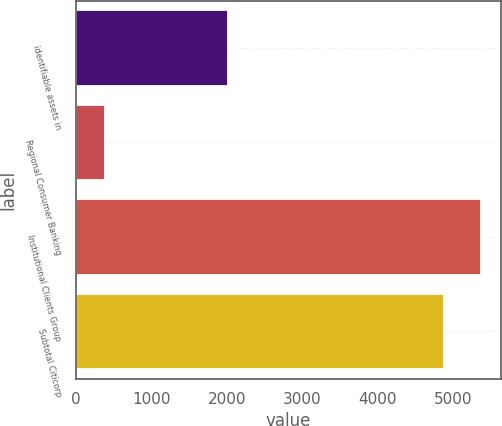Convert chart. <chart><loc_0><loc_0><loc_500><loc_500><bar_chart><fcel>identifiable assets in<fcel>Regional Consumer Banking<fcel>Institutional Clients Group<fcel>Subtotal Citicorp<nl><fcel>2009<fcel>386<fcel>5362.5<fcel>4875<nl></chart> 